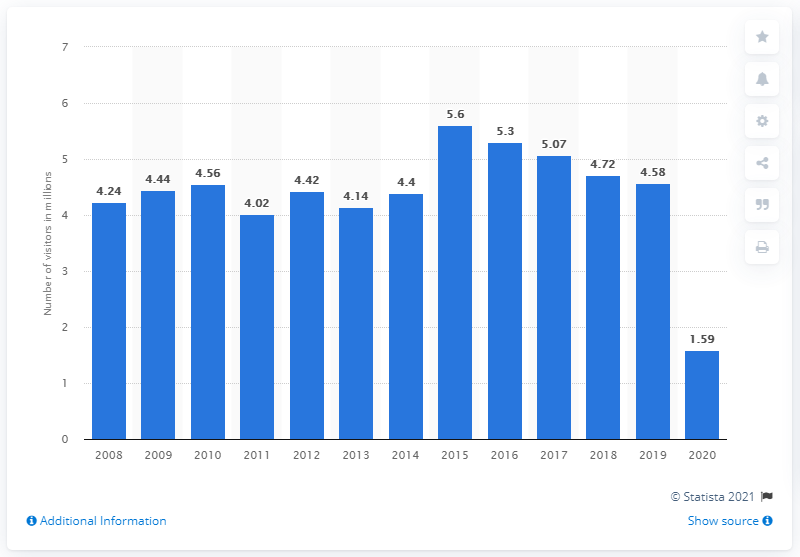Give some essential details in this illustration. In 2020, the Vietnam Veterans Memorial was visited by 1.59 million people. 